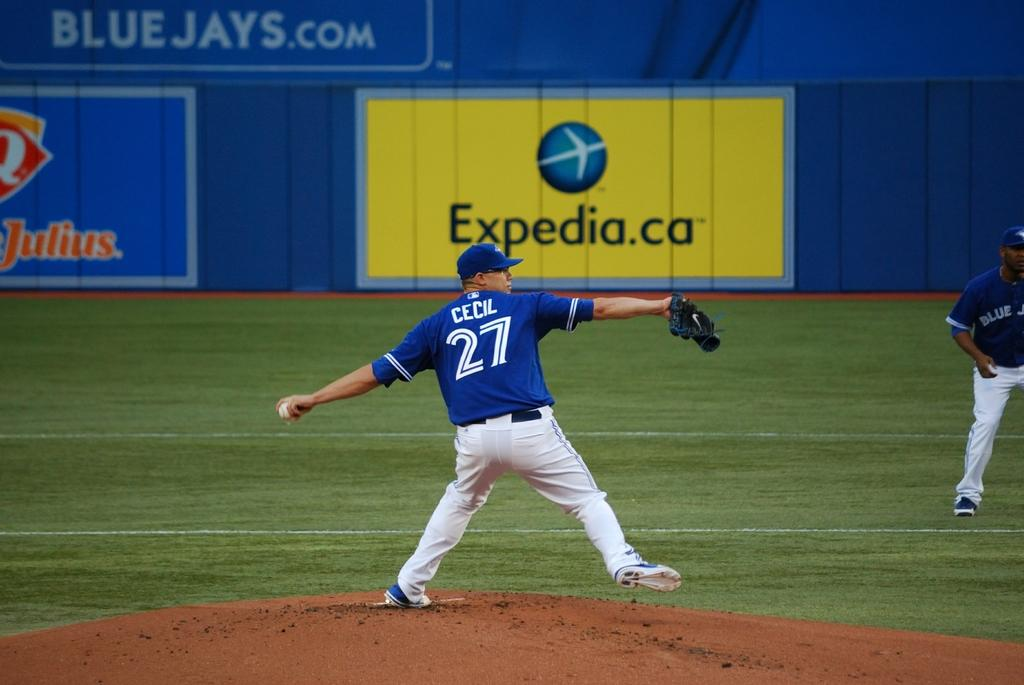<image>
Summarize the visual content of the image. Number 27 throws out the pitch at a baseball statium sponsored by Expedia. 